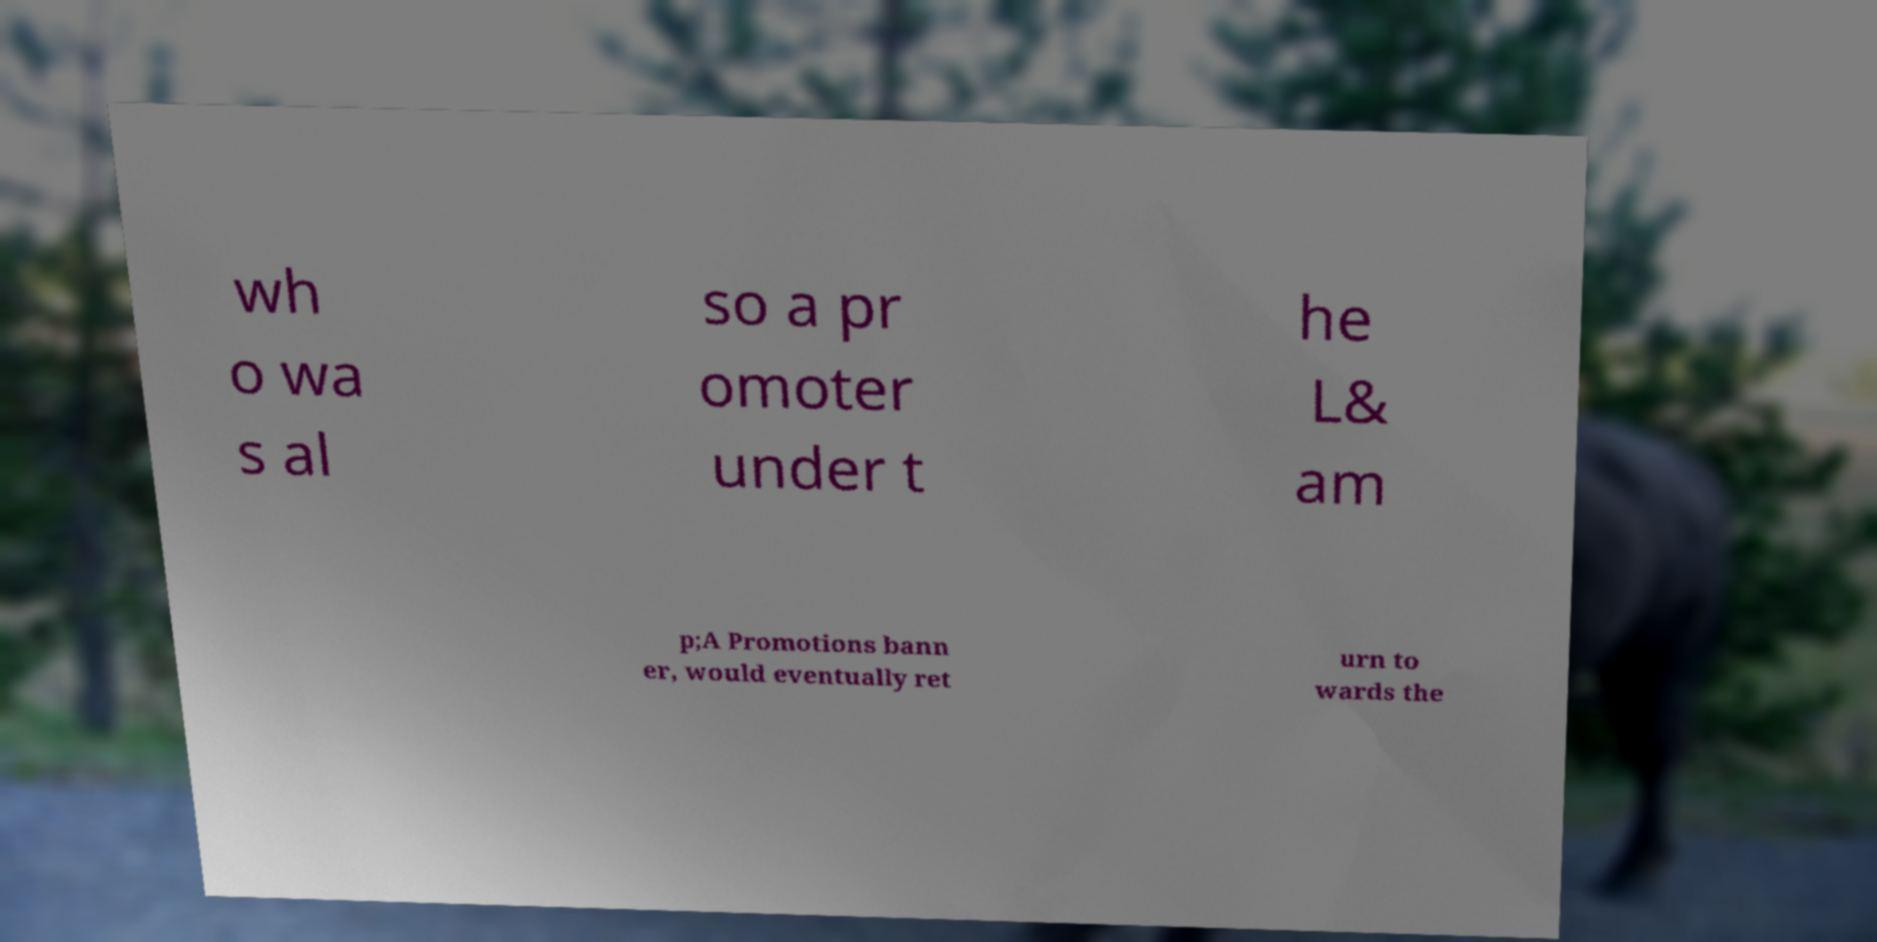Can you read and provide the text displayed in the image?This photo seems to have some interesting text. Can you extract and type it out for me? wh o wa s al so a pr omoter under t he L& am p;A Promotions bann er, would eventually ret urn to wards the 